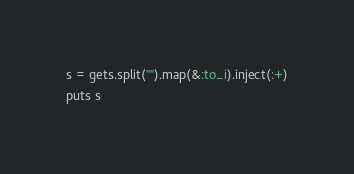Convert code to text. <code><loc_0><loc_0><loc_500><loc_500><_Ruby_>s = gets.split("").map(&:to_i).inject(:+)
puts s</code> 